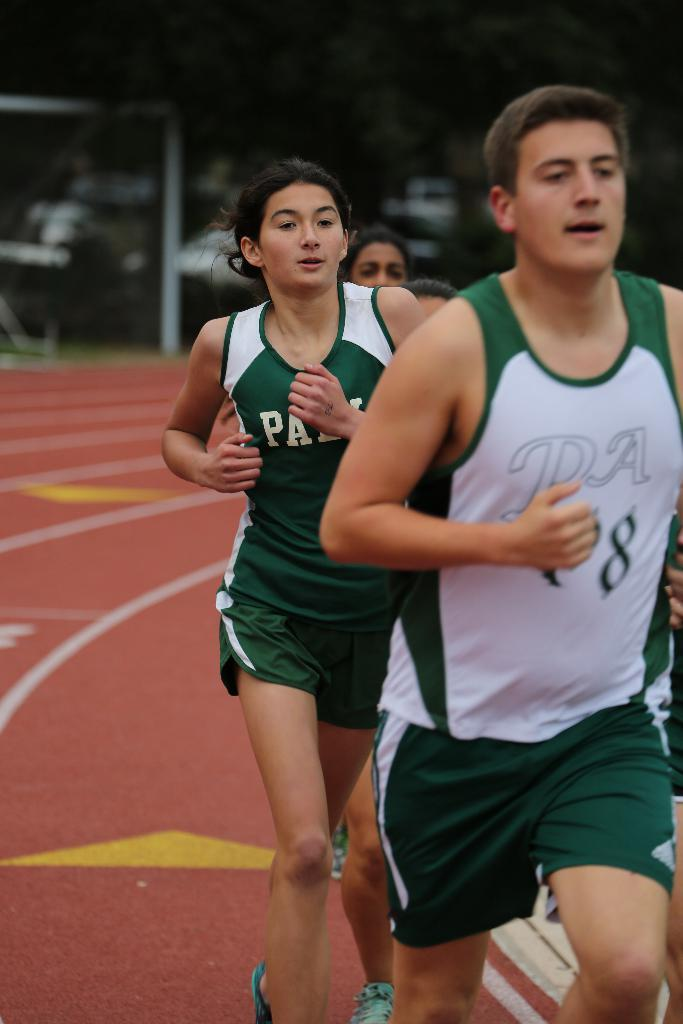<image>
Relay a brief, clear account of the picture shown. A group of people are running a track and wearing tank tops that say PA. 